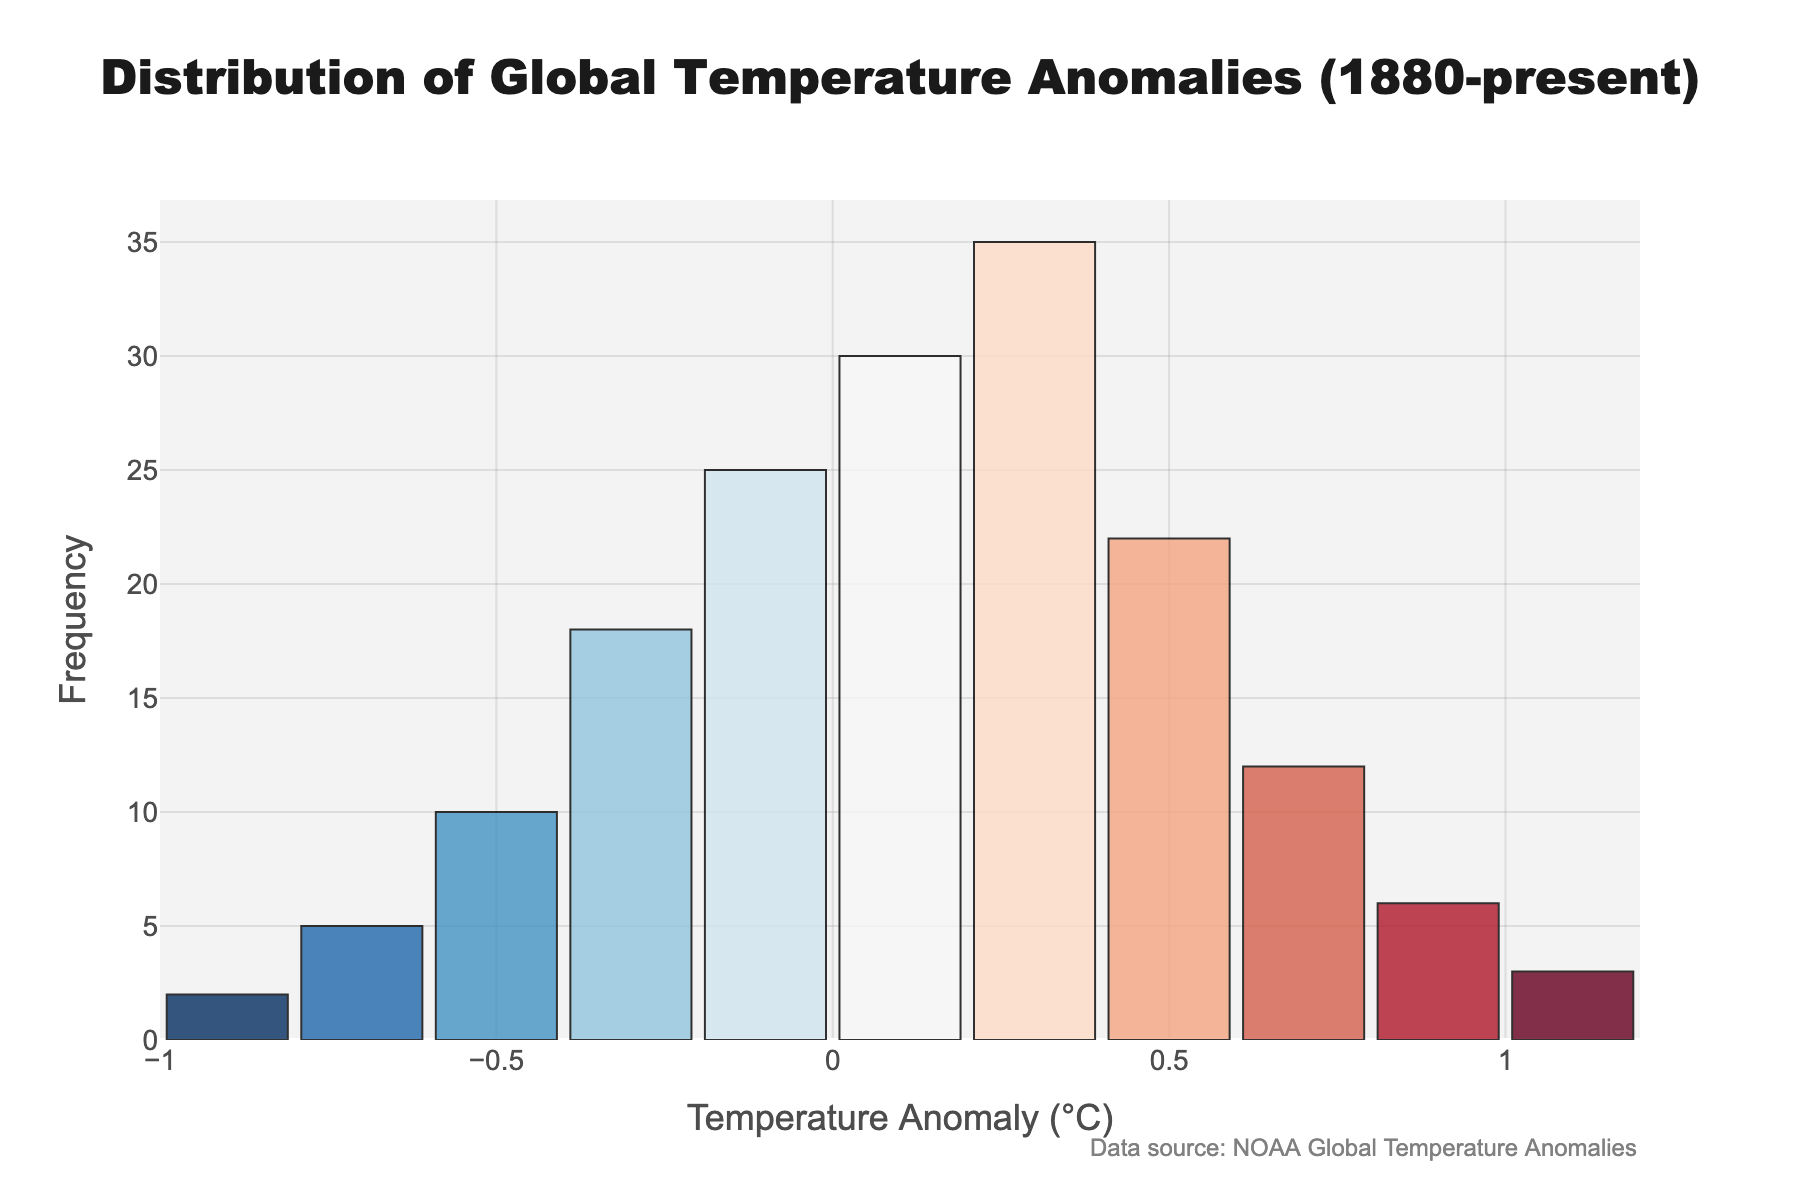What is the title of the histogram? The title is located at the top center of the histogram and describes what the figure represents.
Answer: "Distribution of Global Temperature Anomalies (1880-present)" What is the most frequent range of temperature anomalies? Identify the bar with the highest frequency on the y-axis and refer to its corresponding range on the x-axis.
Answer: 0.2 to 0.4 How many temperature anomaly ranges have a negative value? Count the number of bars representing negative temperature anomaly ranges on the x-axis.
Answer: 5 What is the frequency of the temperature anomaly range from 0.6 to 0.8? Locate the bar at the range 0.6 to 0.8 on the x-axis and refer to its height on the y-axis.
Answer: 12 Which anomaly range has the lowest frequency? Identify the bar with the lowest height on the y-axis and refer to its corresponding range on the x-axis.
Answer: -1.0 to -0.8 How many times does the temperature anomaly range from -0.4 to -0.2 occur compared to the range from 1.0 to 1.2? Find the frequencies of both ranges from the y-axis and compare them by division. Frequency of -0.4 to -0.2 is 18 and frequency of 1.0 to 1.2 is 3, so 18 / 3 = 6 times.
Answer: 6 times What is the average frequency of temperature anomalies between -0.6 and 1.2? Add the frequencies of all bars from -0.6 to 1.2 and divide by the number of bars. Sum = 10 + 18 + 25 + 30 + 35 + 22 + 12 + 6 + 3 = 161, Number of bars = 9, Average = 161 / 9 ≈ 17.89
Answer: 17.89 